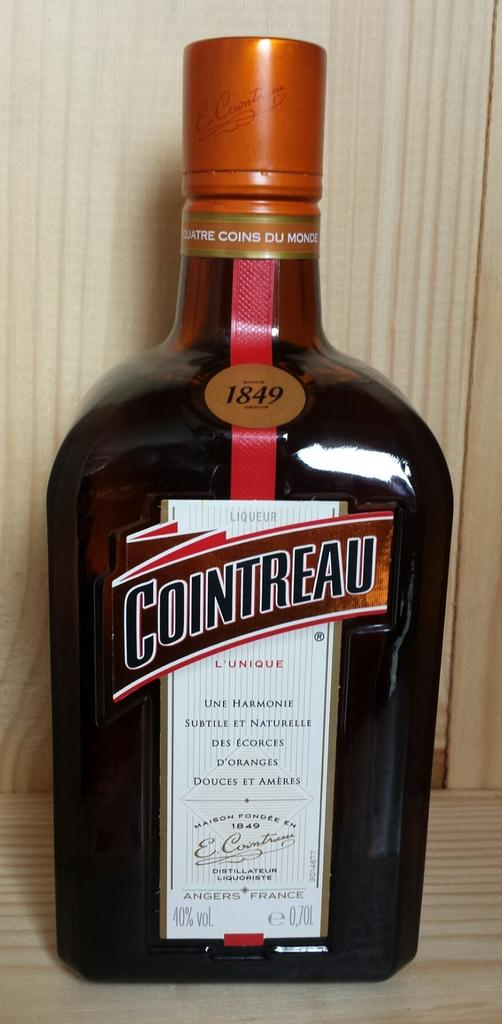<image>
Relay a brief, clear account of the picture shown. a close up of a bottle of Cointreau from 1849 